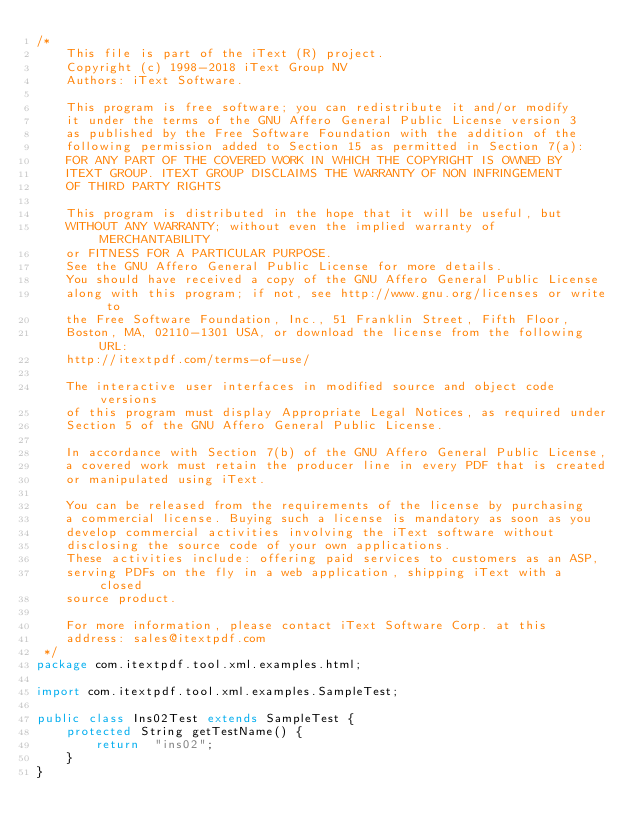Convert code to text. <code><loc_0><loc_0><loc_500><loc_500><_Java_>/*
    This file is part of the iText (R) project.
    Copyright (c) 1998-2018 iText Group NV
    Authors: iText Software.

    This program is free software; you can redistribute it and/or modify
    it under the terms of the GNU Affero General Public License version 3
    as published by the Free Software Foundation with the addition of the
    following permission added to Section 15 as permitted in Section 7(a):
    FOR ANY PART OF THE COVERED WORK IN WHICH THE COPYRIGHT IS OWNED BY
    ITEXT GROUP. ITEXT GROUP DISCLAIMS THE WARRANTY OF NON INFRINGEMENT
    OF THIRD PARTY RIGHTS
    
    This program is distributed in the hope that it will be useful, but
    WITHOUT ANY WARRANTY; without even the implied warranty of MERCHANTABILITY
    or FITNESS FOR A PARTICULAR PURPOSE.
    See the GNU Affero General Public License for more details.
    You should have received a copy of the GNU Affero General Public License
    along with this program; if not, see http://www.gnu.org/licenses or write to
    the Free Software Foundation, Inc., 51 Franklin Street, Fifth Floor,
    Boston, MA, 02110-1301 USA, or download the license from the following URL:
    http://itextpdf.com/terms-of-use/
    
    The interactive user interfaces in modified source and object code versions
    of this program must display Appropriate Legal Notices, as required under
    Section 5 of the GNU Affero General Public License.
    
    In accordance with Section 7(b) of the GNU Affero General Public License,
    a covered work must retain the producer line in every PDF that is created
    or manipulated using iText.
    
    You can be released from the requirements of the license by purchasing
    a commercial license. Buying such a license is mandatory as soon as you
    develop commercial activities involving the iText software without
    disclosing the source code of your own applications.
    These activities include: offering paid services to customers as an ASP,
    serving PDFs on the fly in a web application, shipping iText with a closed
    source product.
    
    For more information, please contact iText Software Corp. at this
    address: sales@itextpdf.com
 */
package com.itextpdf.tool.xml.examples.html;

import com.itextpdf.tool.xml.examples.SampleTest;

public class Ins02Test extends SampleTest {
    protected String getTestName() {
        return  "ins02";
    }
}
</code> 